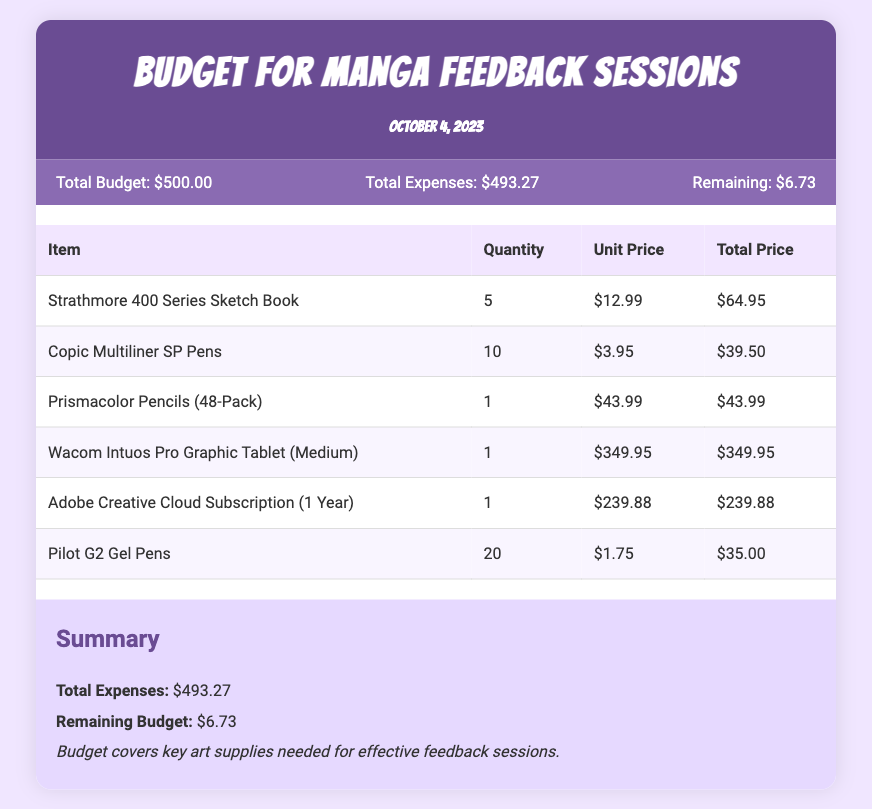What is the total budget? The total budget is indicated in the budget info section of the document as $500.00.
Answer: $500.00 What is the total expenses amount? The total expenses are listed in the budget info section as $493.27.
Answer: $493.27 How many Strathmore 400 Series Sketch Books were purchased? The quantity of Strathmore 400 Series Sketch Books is stated in the budget table as 5.
Answer: 5 What is the unit price of Copic Multiliner SP Pens? The unit price for Copic Multiliner SP Pens is mentioned in the budget table as $3.95.
Answer: $3.95 What digital tool is included in the budget? The Wacom Intuos Pro Graphic Tablet (Medium) is the digital tool listed in the budget table.
Answer: Wacom Intuos Pro Graphic Tablet (Medium) What is the remaining budget after expenses? The remaining budget after subtracting total expenses from the total budget is specified as $6.73.
Answer: $6.73 How much did the Adobe Creative Cloud Subscription cost? The cost for the Adobe Creative Cloud Subscription is provided as $239.88 in the budget table.
Answer: $239.88 What type of document is this? This document is a budget overview specifically for manga feedback sessions.
Answer: Budget overview What is the purpose of the budget? The budget covers key art supplies needed for effective feedback sessions, as indicated in the summary section.
Answer: Effective feedback sessions 